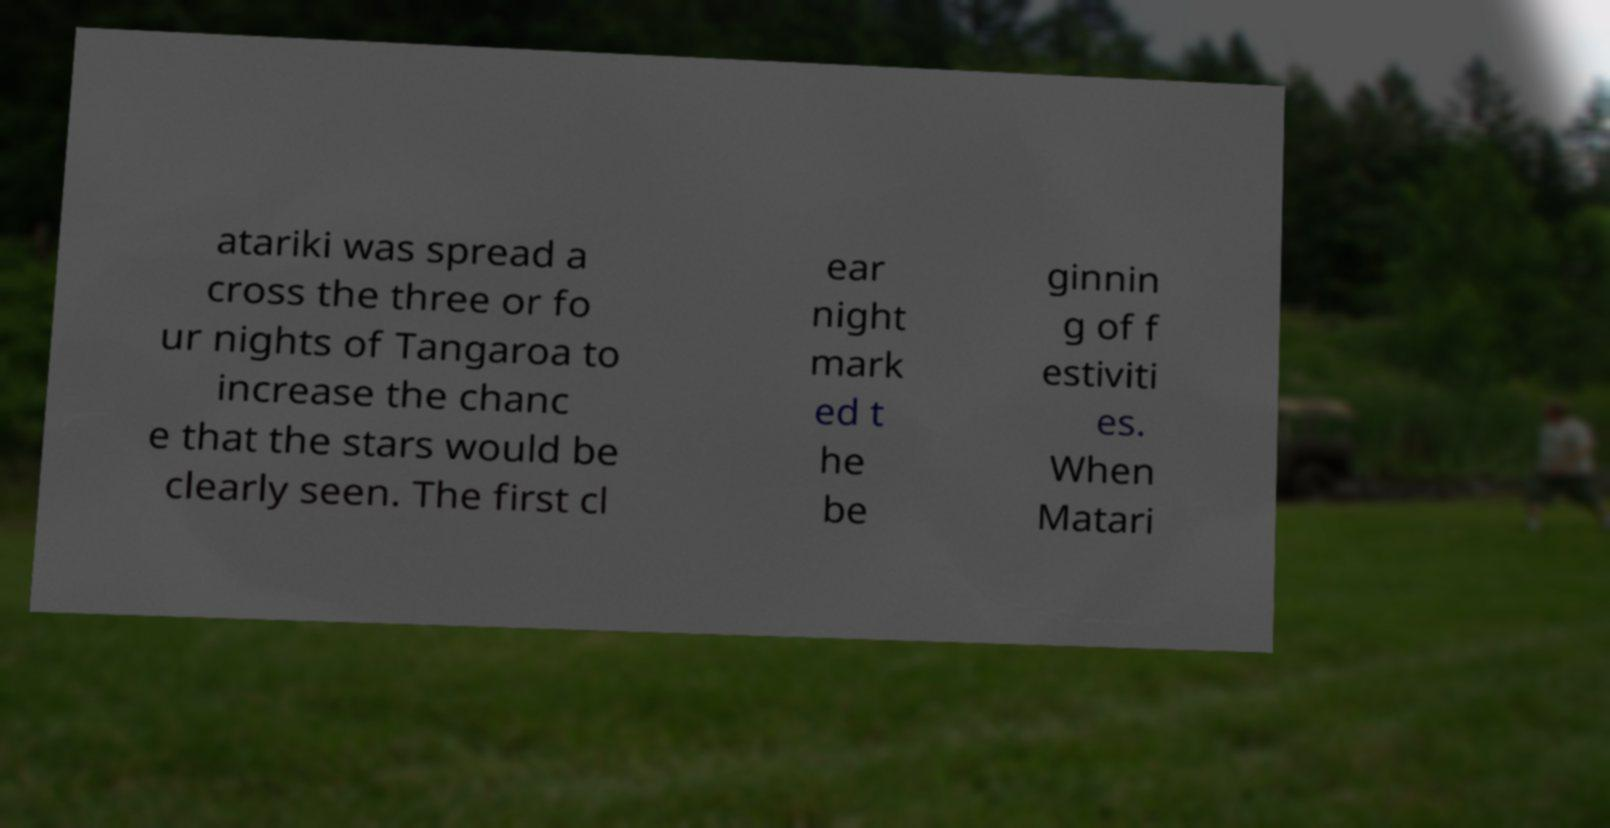Please identify and transcribe the text found in this image. atariki was spread a cross the three or fo ur nights of Tangaroa to increase the chanc e that the stars would be clearly seen. The first cl ear night mark ed t he be ginnin g of f estiviti es. When Matari 